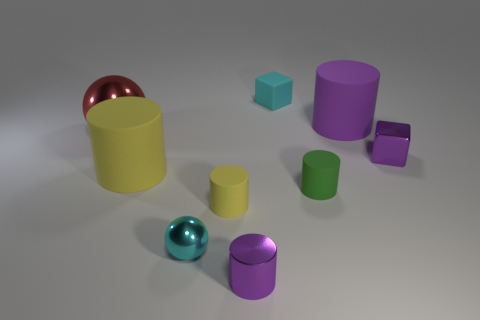What is the shape of the tiny thing that is both in front of the small green cylinder and behind the cyan ball?
Provide a short and direct response. Cylinder. What color is the big rubber thing left of the tiny metallic ball?
Offer a very short reply. Yellow. Is there any other thing that is the same color as the big ball?
Your answer should be compact. No. Do the red metal thing and the metallic cube have the same size?
Your response must be concise. No. How big is the rubber cylinder that is in front of the big yellow rubber thing and to the left of the cyan cube?
Give a very brief answer. Small. How many purple cubes have the same material as the red object?
Provide a succinct answer. 1. There is a small rubber object that is the same color as the tiny ball; what shape is it?
Your answer should be very brief. Cube. The small metal cube is what color?
Keep it short and to the point. Purple. There is a purple object that is behind the red shiny object; is its shape the same as the large yellow thing?
Offer a terse response. Yes. How many things are either things that are to the left of the tiny purple metallic cylinder or purple shiny balls?
Your answer should be very brief. 4. 